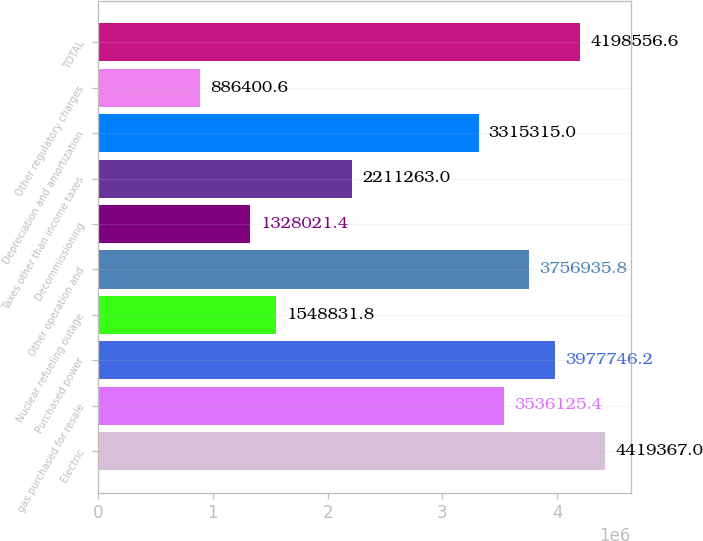<chart> <loc_0><loc_0><loc_500><loc_500><bar_chart><fcel>Electric<fcel>gas purchased for resale<fcel>Purchased power<fcel>Nuclear refueling outage<fcel>Other operation and<fcel>Decommissioning<fcel>Taxes other than income taxes<fcel>Depreciation and amortization<fcel>Other regulatory charges<fcel>TOTAL<nl><fcel>4.41937e+06<fcel>3.53613e+06<fcel>3.97775e+06<fcel>1.54883e+06<fcel>3.75694e+06<fcel>1.32802e+06<fcel>2.21126e+06<fcel>3.31532e+06<fcel>886401<fcel>4.19856e+06<nl></chart> 